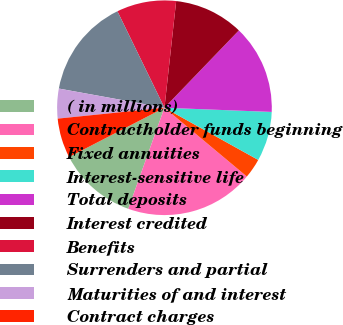Convert chart. <chart><loc_0><loc_0><loc_500><loc_500><pie_chart><fcel>( in millions)<fcel>Contractholder funds beginning<fcel>Fixed annuities<fcel>Interest-sensitive life<fcel>Total deposits<fcel>Interest credited<fcel>Benefits<fcel>Surrenders and partial<fcel>Maturities of and interest<fcel>Contract charges<nl><fcel>11.94%<fcel>19.4%<fcel>2.99%<fcel>7.46%<fcel>13.43%<fcel>10.45%<fcel>8.96%<fcel>14.92%<fcel>4.48%<fcel>5.97%<nl></chart> 